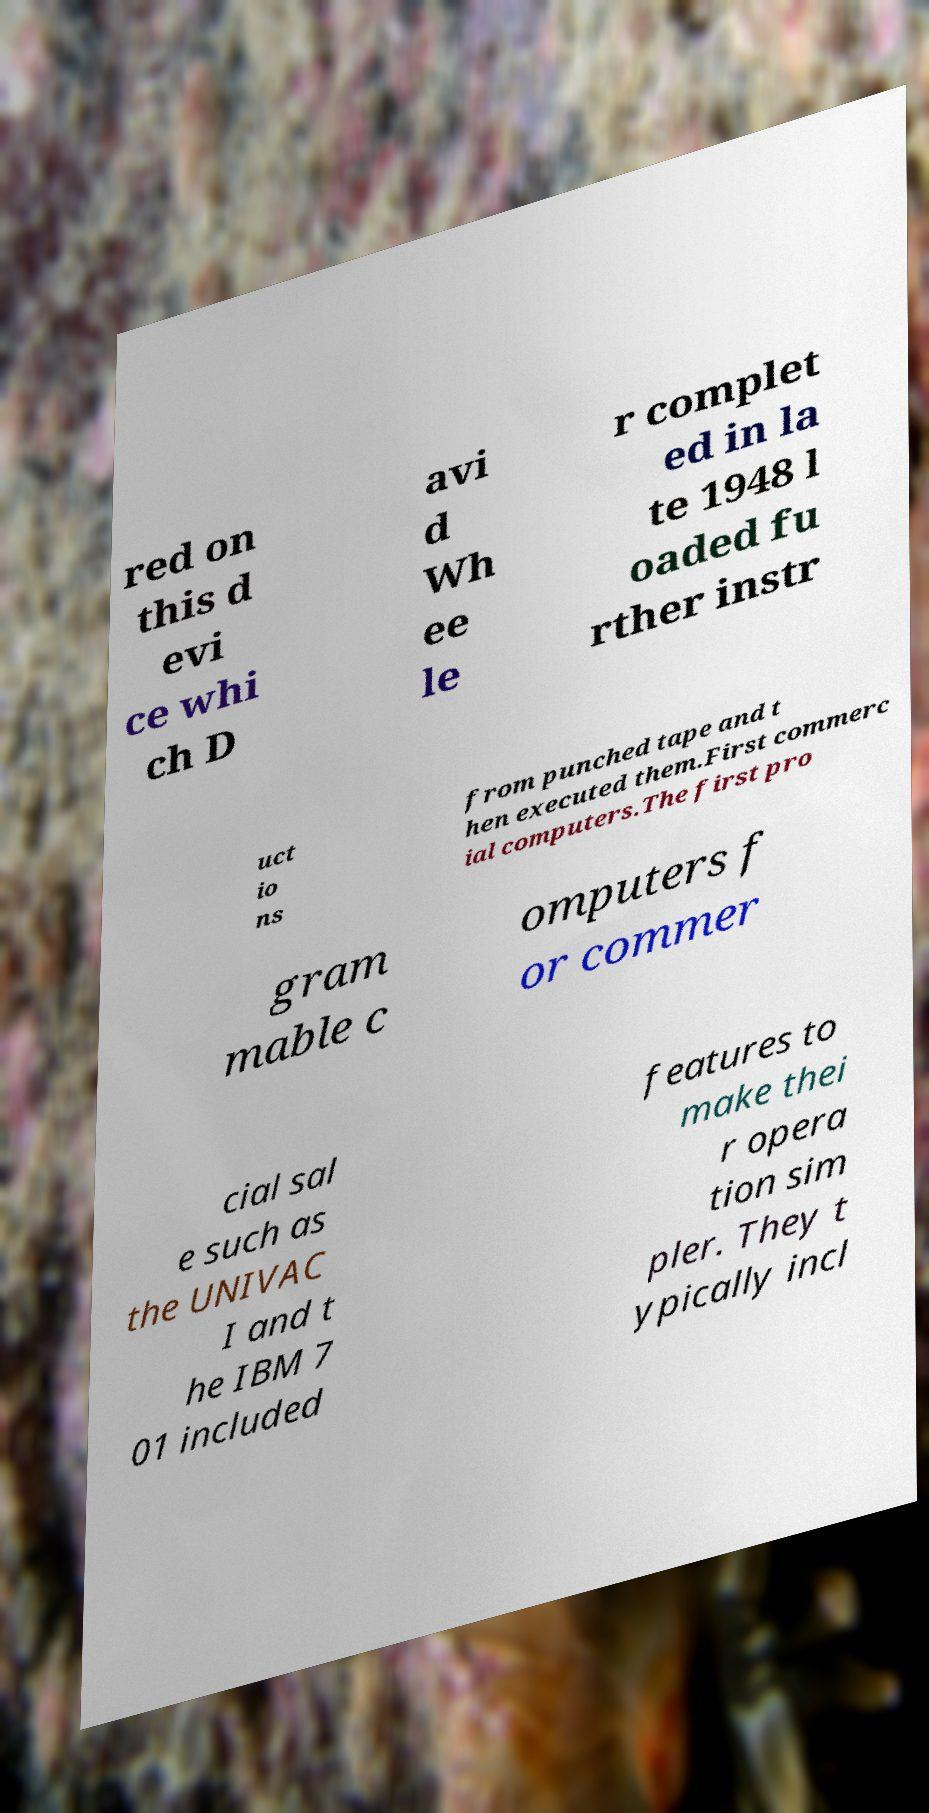What messages or text are displayed in this image? I need them in a readable, typed format. red on this d evi ce whi ch D avi d Wh ee le r complet ed in la te 1948 l oaded fu rther instr uct io ns from punched tape and t hen executed them.First commerc ial computers.The first pro gram mable c omputers f or commer cial sal e such as the UNIVAC I and t he IBM 7 01 included features to make thei r opera tion sim pler. They t ypically incl 